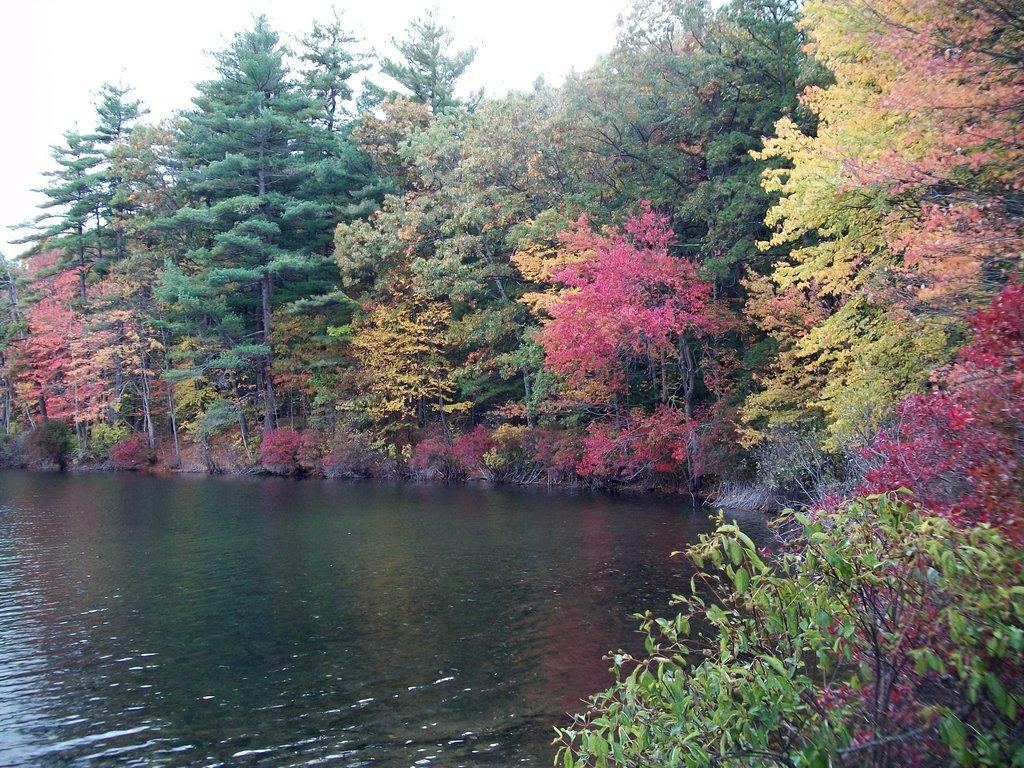What type of vegetation can be seen in the image? There are trees in the image. What natural element is visible besides the trees? There is water visible in the image. What can be seen in the background of the image? The sky is visible in the background of the image. What type of bulb is being used for the activity with the pets in the image? There is no bulb, activity, or pets present in the image. 